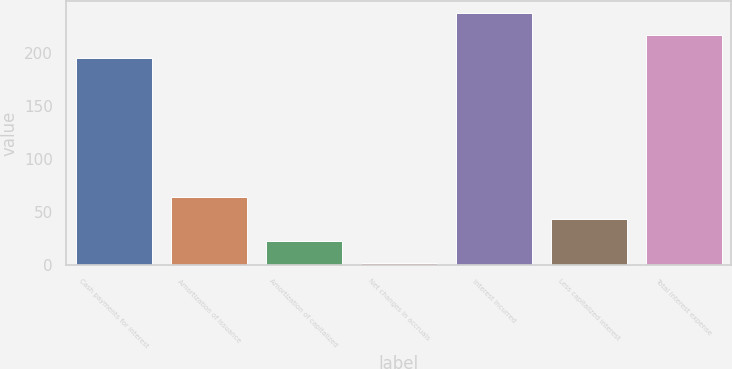Convert chart to OTSL. <chart><loc_0><loc_0><loc_500><loc_500><bar_chart><fcel>Cash payments for interest<fcel>Amortization of issuance<fcel>Amortization of capitalized<fcel>Net changes in accruals<fcel>Interest incurred<fcel>Less capitalized interest<fcel>Total interest expense<nl><fcel>196<fcel>64.7<fcel>22.9<fcel>2<fcel>237.8<fcel>43.8<fcel>216.9<nl></chart> 